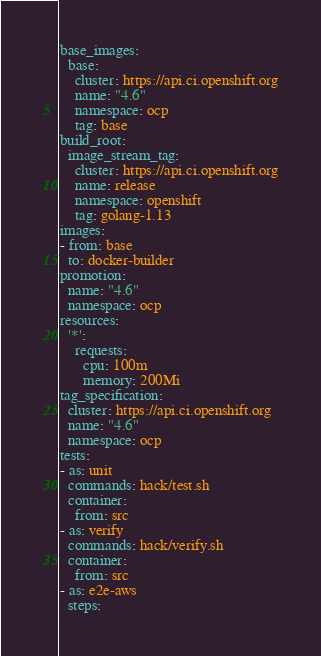Convert code to text. <code><loc_0><loc_0><loc_500><loc_500><_YAML_>base_images:
  base:
    cluster: https://api.ci.openshift.org
    name: "4.6"
    namespace: ocp
    tag: base
build_root:
  image_stream_tag:
    cluster: https://api.ci.openshift.org
    name: release
    namespace: openshift
    tag: golang-1.13
images:
- from: base
  to: docker-builder
promotion:
  name: "4.6"
  namespace: ocp
resources:
  '*':
    requests:
      cpu: 100m
      memory: 200Mi
tag_specification:
  cluster: https://api.ci.openshift.org
  name: "4.6"
  namespace: ocp
tests:
- as: unit
  commands: hack/test.sh
  container:
    from: src
- as: verify
  commands: hack/verify.sh
  container:
    from: src
- as: e2e-aws
  steps:</code> 